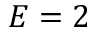<formula> <loc_0><loc_0><loc_500><loc_500>E = 2</formula> 